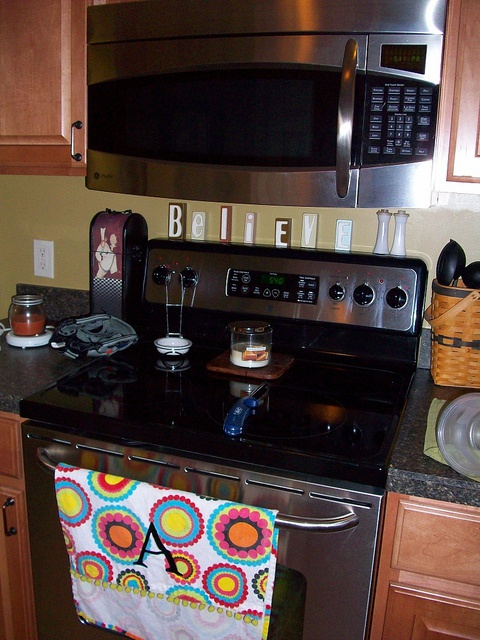Describe the objects in this image and their specific colors. I can see oven in maroon, black, gray, and lavender tones, microwave in maroon, black, gray, and white tones, and spoon in maroon, black, gray, and darkblue tones in this image. 